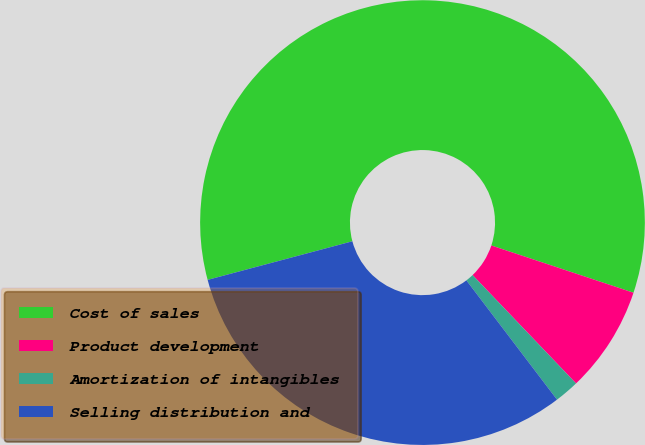Convert chart to OTSL. <chart><loc_0><loc_0><loc_500><loc_500><pie_chart><fcel>Cost of sales<fcel>Product development<fcel>Amortization of intangibles<fcel>Selling distribution and<nl><fcel>59.25%<fcel>7.76%<fcel>1.79%<fcel>31.19%<nl></chart> 